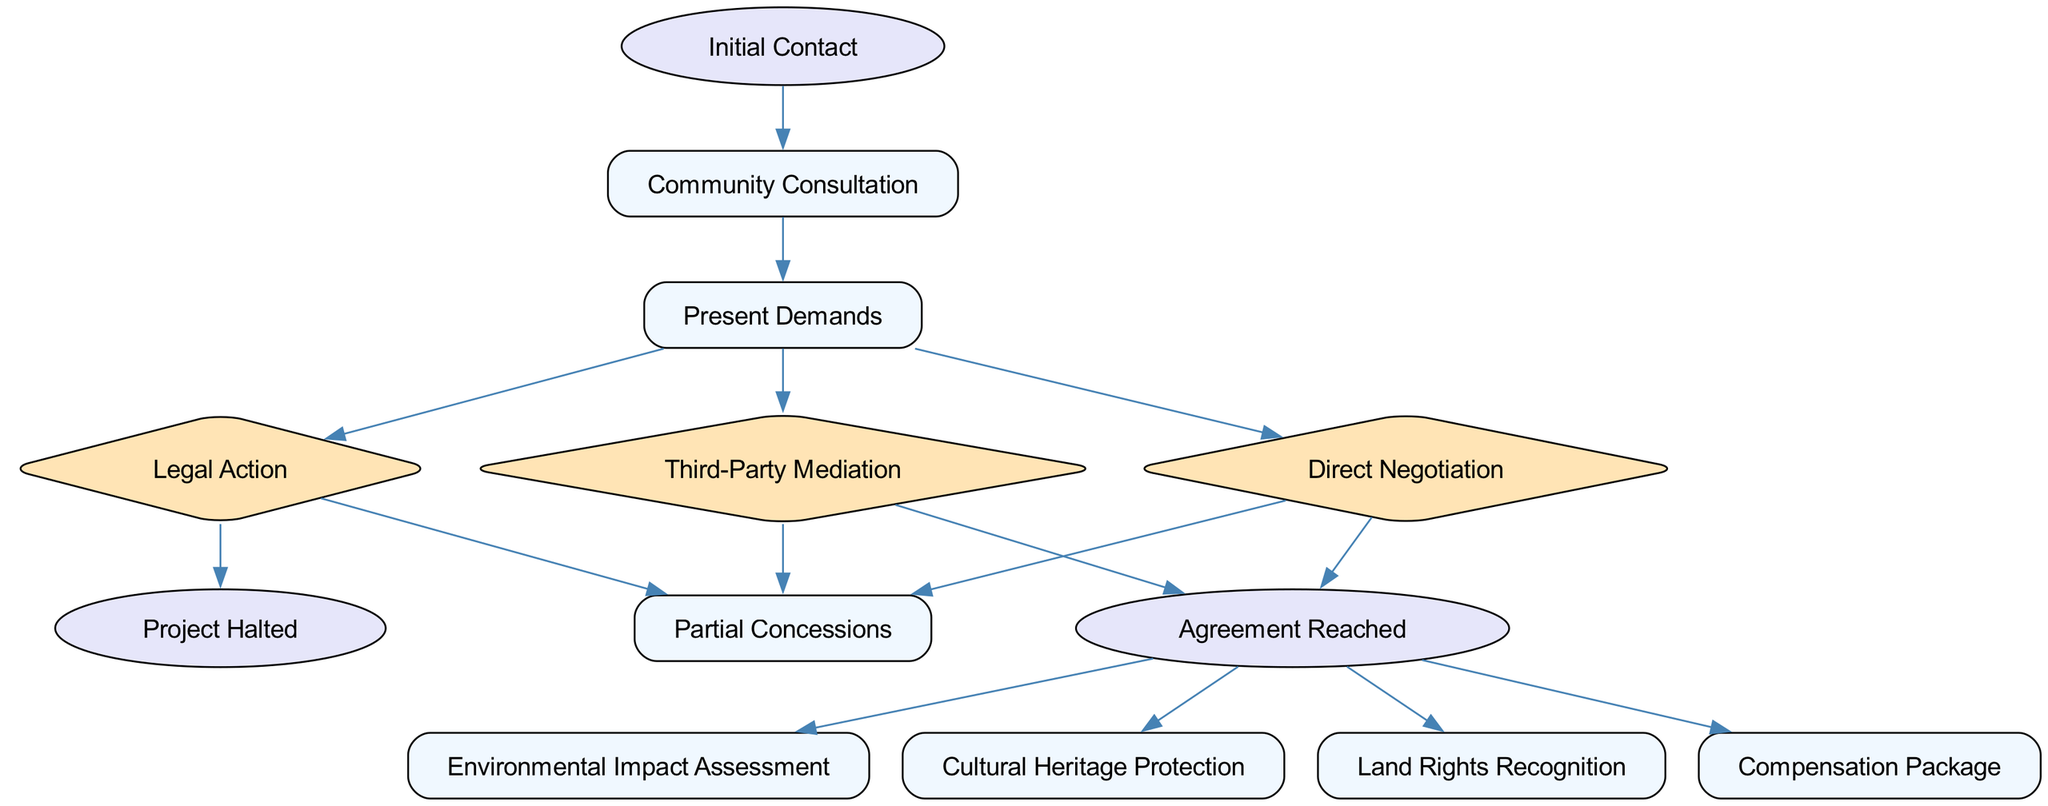What is the starting point of the negotiation strategies? The diagram indicates that the starting point of the negotiation strategies is "Initial Contact." This node is the first in the directed graph, establishing the beginning of the negotiation process with industrial companies.
Answer: Initial Contact How many nodes are there in total? To determine the total number of nodes, we need to count the unique entries in the "nodes" list provided. There are 14 distinct nodes outlined, which represent various steps and outcomes in the negotiation strategies.
Answer: 14 What happens after "Legal Action"? "Legal Action" connects to two outcomes: "Project Halted" and "Partial Concessions." This indicates that if legal action is pursued, either the project may be halted or partial concessions can be achieved from the industrial companies.
Answer: Project Halted, Partial Concessions Which negotiation strategy leads directly to "Agreement Reached"? The diagram shows two direct paths leading to "Agreement Reached": one from "Direct Negotiation" and another from "Third-Party Mediation." This indicates that engaging directly with the company or involving a third-party mediator can both result in reaching an agreement.
Answer: Direct Negotiation, Third-Party Mediation What are the consequences of reaching an agreement? Upon "Agreement Reached," there are several potential consequences or outcomes that can occur: "Environmental Impact Assessment," "Cultural Heritage Protection," "Land Rights Recognition," and "Compensation Package." This indicates that an agreement can lead to various protective measures and compensations related to the project.
Answer: Environmental Impact Assessment, Cultural Heritage Protection, Land Rights Recognition, Compensation Package What node indicates a complete halt to the project? The node representing a complete halt of the project is "Project Halted." This outcome implies that the negotiation or legal actions have successfully prevented the industrial project from proceeding.
Answer: Project Halted Which nodes represent decision points in the negotiation process? The decision points in the negotiation process are represented by the nodes "Legal Action," "Direct Negotiation," and "Third-Party Mediation." These nodes are shaped as diamonds in the diagram, indicating critical junctures where different strategies can be employed.
Answer: Legal Action, Direct Negotiation, Third-Party Mediation What strategies can follow the presentation of demands? After the "Present Demands" node, three strategies can be pursued: "Legal Action," "Direct Negotiation," and "Third-Party Mediation." This indicates the possible pathways available to the community after they express their demands to the industrial companies.
Answer: Legal Action, Direct Negotiation, Third-Party Mediation How does the diagram reflect the complexity of negotiation paths? The diagram illustrates the complexity of negotiation paths by showing multiple branches stemming from key decision points, such as "Present Demands," which leads to various strategies; this branching reveals the different possible outcomes based on the chosen path, emphasizing the intricate nature of negotiations.
Answer: Multiple branches from key decision points 